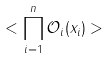Convert formula to latex. <formula><loc_0><loc_0><loc_500><loc_500>< \prod _ { i = 1 } ^ { n } \mathcal { O } _ { i } ( x _ { i } ) ></formula> 